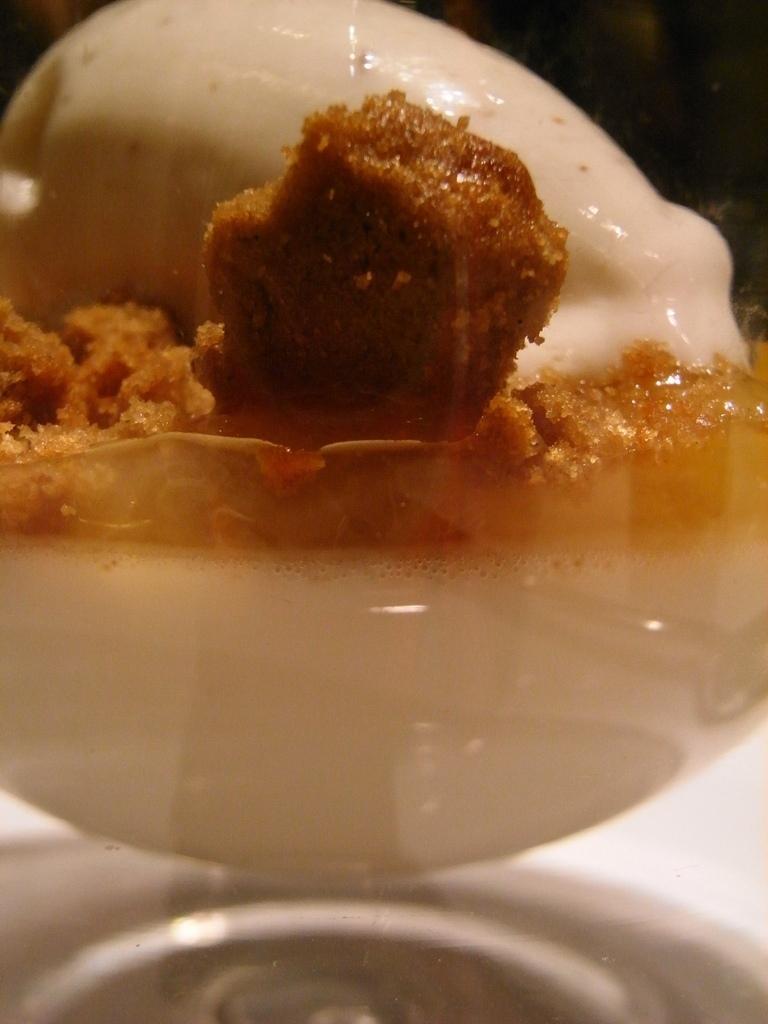In one or two sentences, can you explain what this image depicts? Here we can see food. 